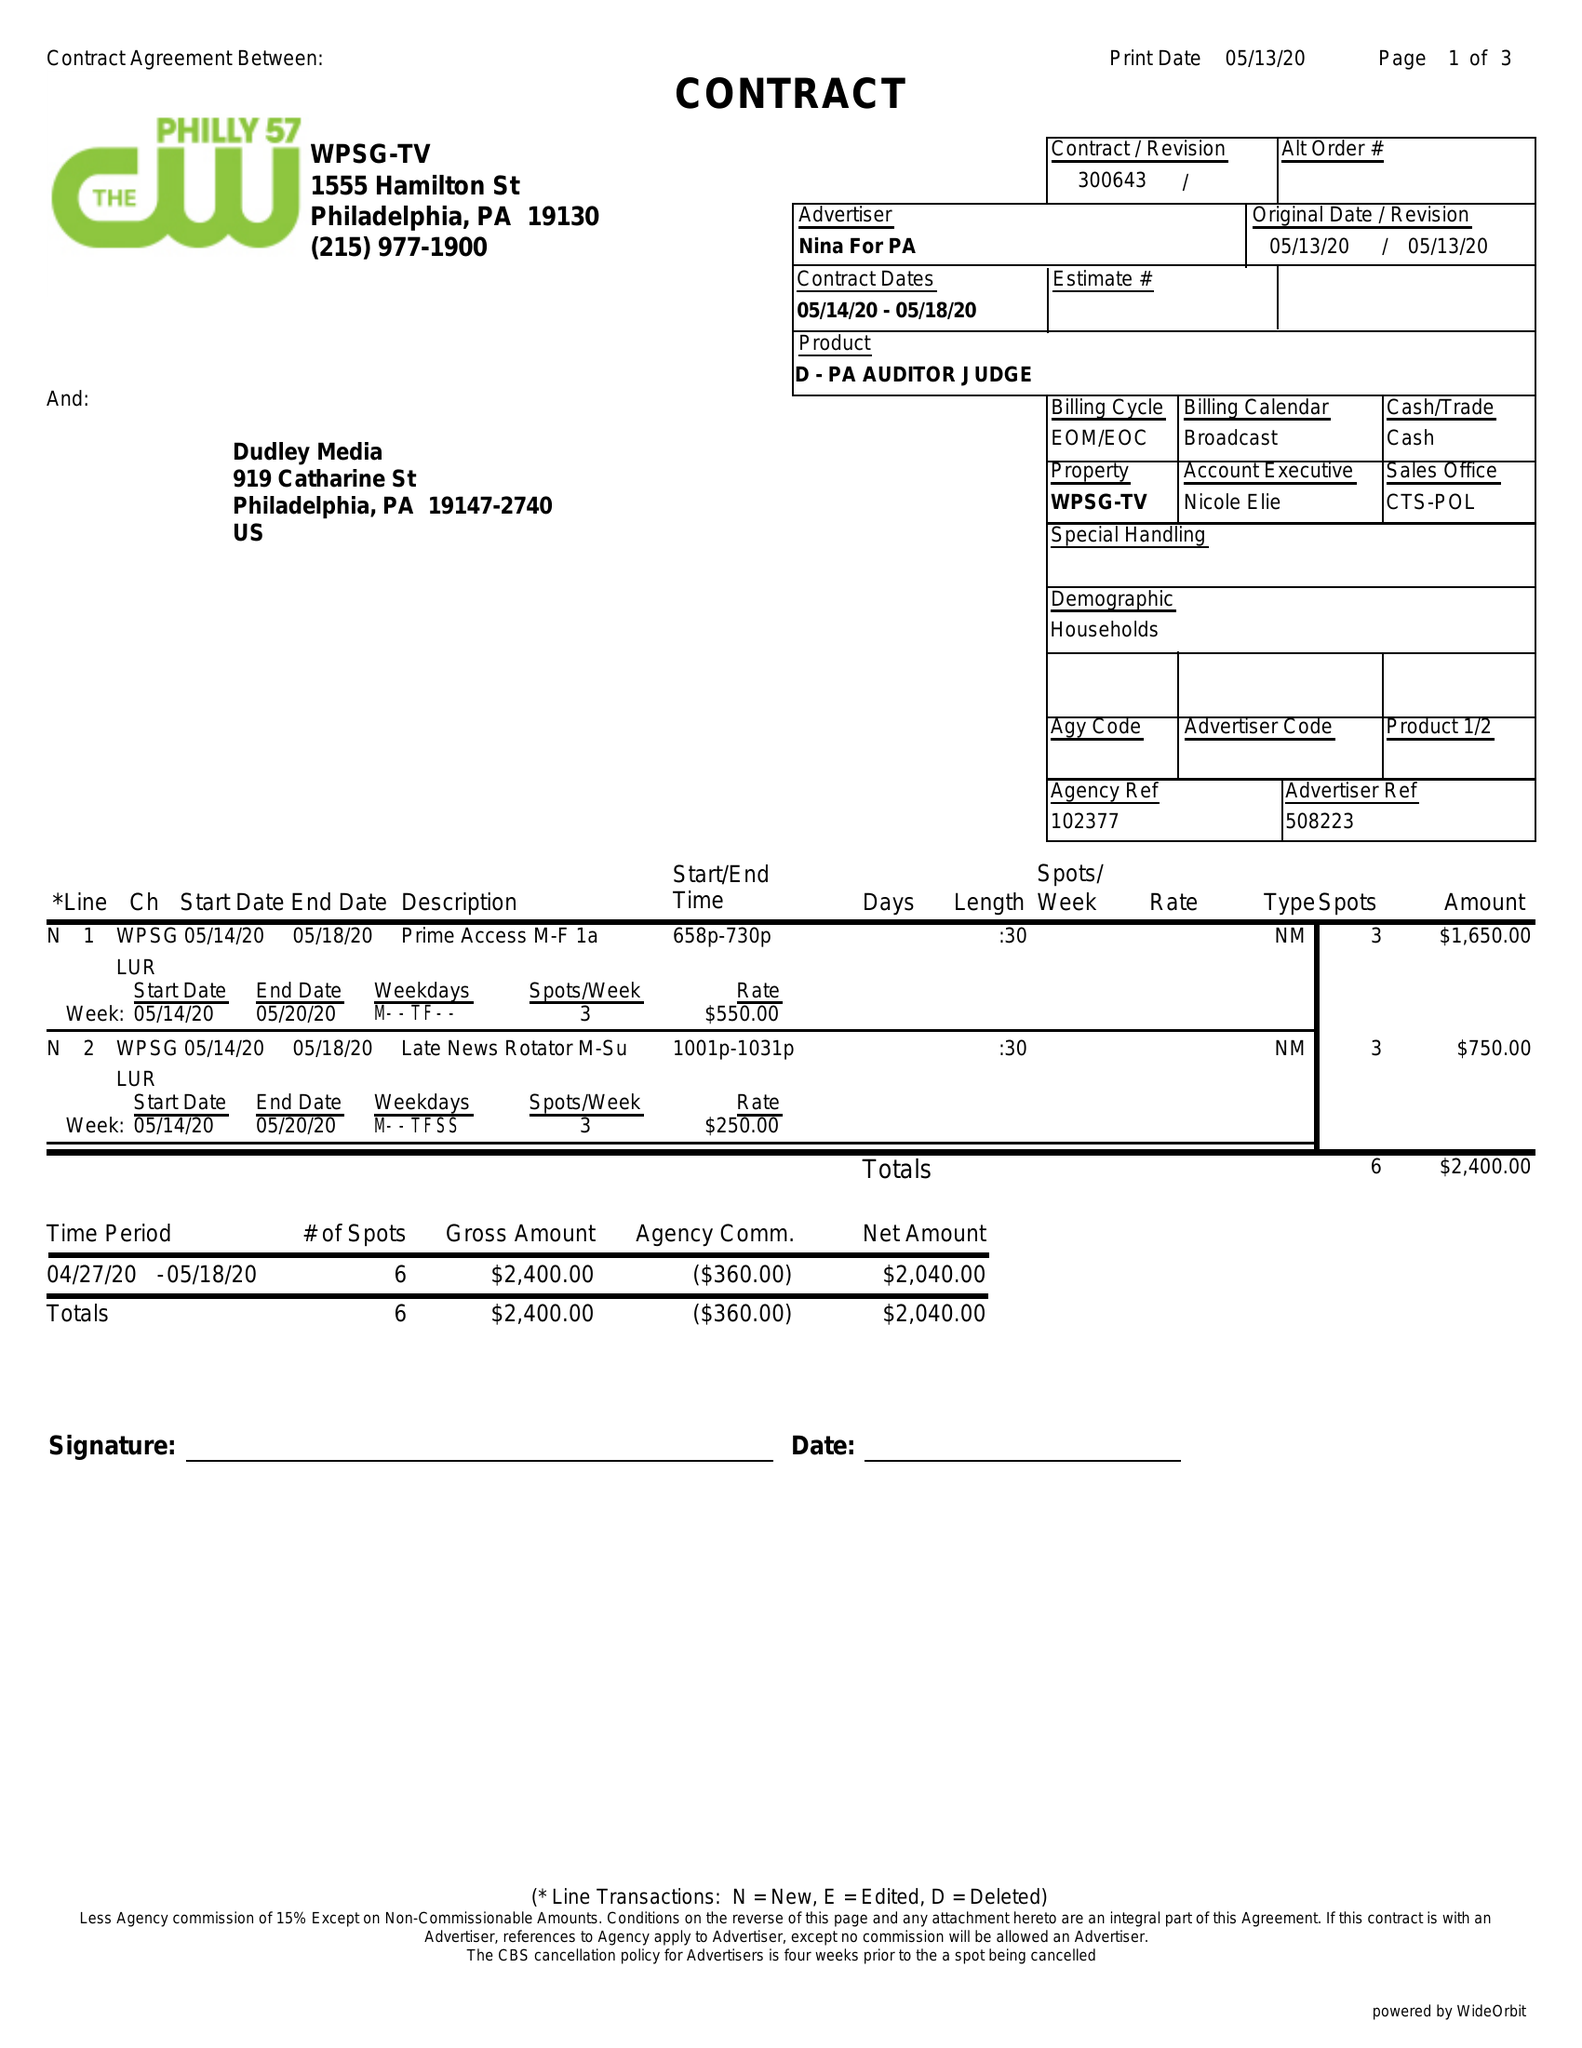What is the value for the contract_num?
Answer the question using a single word or phrase. 300643 